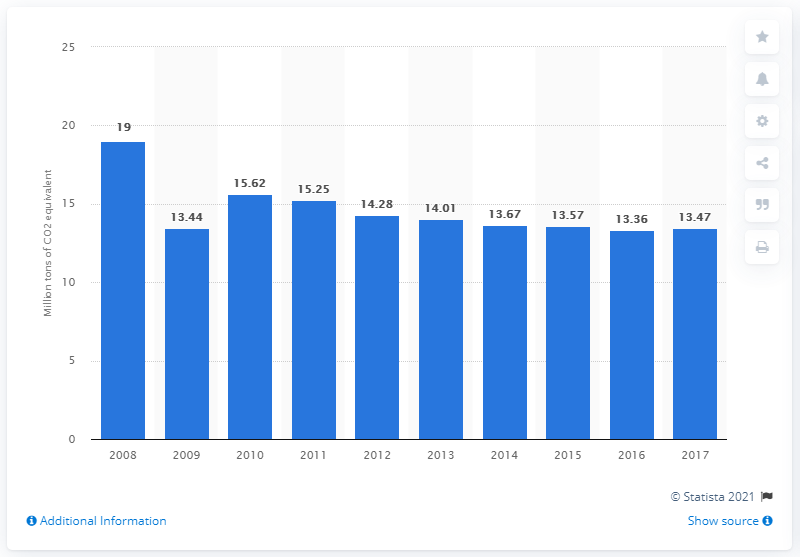Mention a couple of crucial points in this snapshot. In 2017, Belgium emitted 13.47 million metric tons of CO2 equivalent from fuel combustion. 